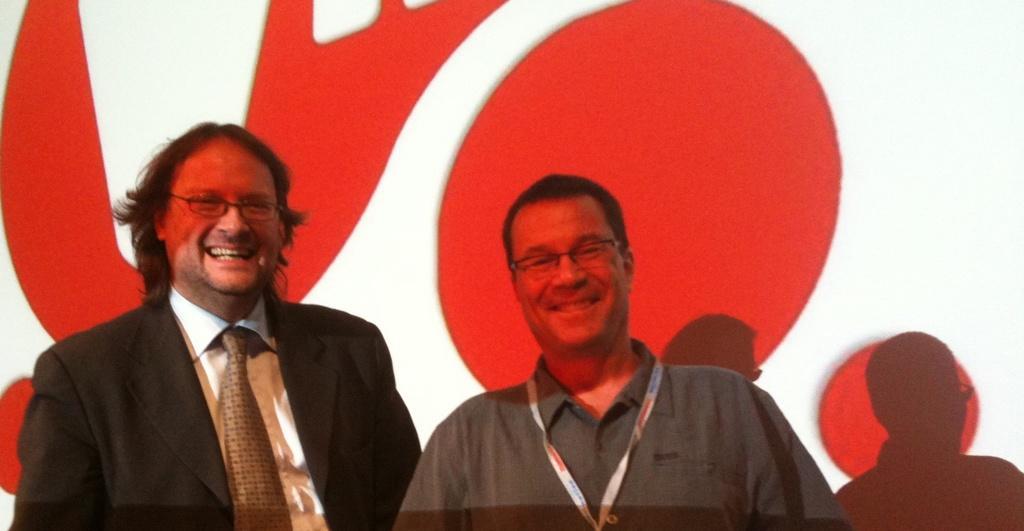How would you summarize this image in a sentence or two? In this image in the center there are two persons who are standing and smiling and in the background there is a wall. 